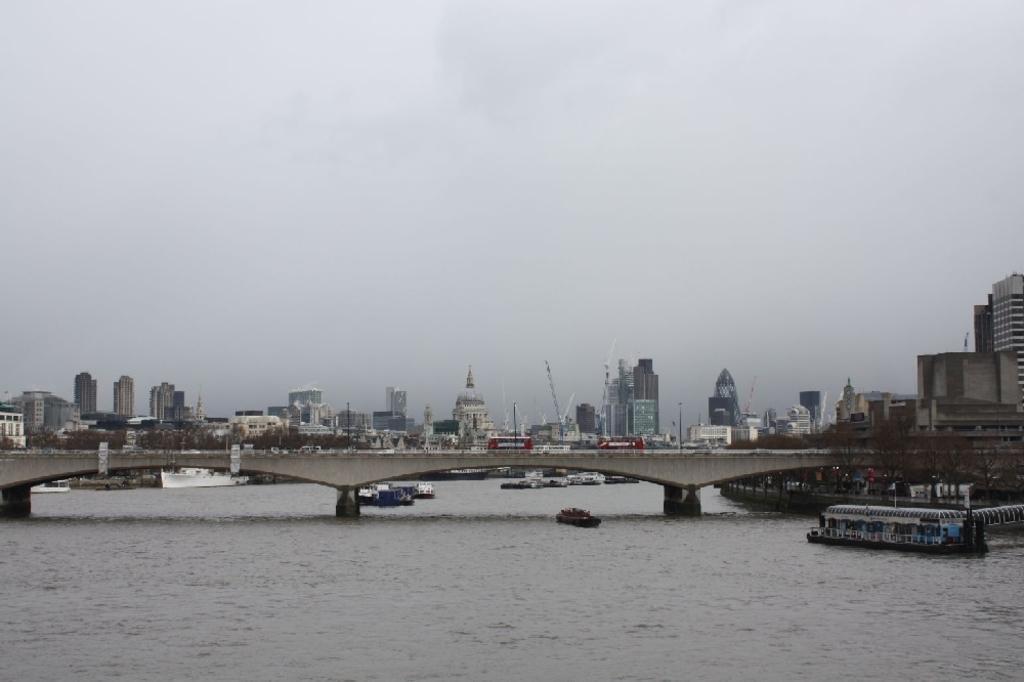Describe this image in one or two sentences. In the image in the center we can see water,boats and bridge. On the bridge,we can see few vehicles. In the background we can see the sky,clouds and buildings. 